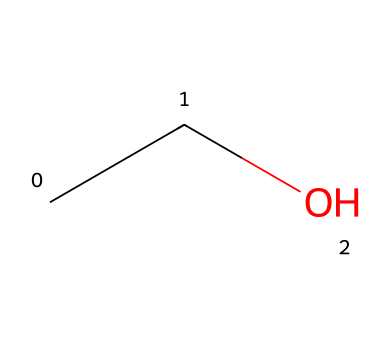What is the name of this chemical? The SMILES representation 'CCO' corresponds to ethanol, which has a hydroxyl (-OH) group attached to a two-carbon alkane.
Answer: ethanol How many carbon atoms are present in this structure? Analyzing the SMILES 'CCO', it consists of two 'C' letters, indicating there are two carbon atoms in the molecule.
Answer: 2 What type of compound is ethanol? Ethanol is classified as a non-electrolyte because it does not dissociate into ions when dissolved in water.
Answer: non-electrolyte How many hydroxyl groups are in this chemical? The 'O' in the SMILES indicates a hydroxyl (-OH) group, and there is only one 'O', meaning there is one hydroxyl group in ethanol.
Answer: 1 What is the total number of hydrogen atoms in ethanol? In the structure represented by 'CCO', there are 2 carbon atoms and 1 oxygen (which does not have hydrogen attached directly). Each carbon can bond with three hydrogens; thus, the total number of hydrogen atoms is 6 (C2H6O).
Answer: 6 Is ethanol soluble in water? Ethanol has a polar -OH group which allows it to form hydrogen bonds with water, making it soluble in water.
Answer: yes 